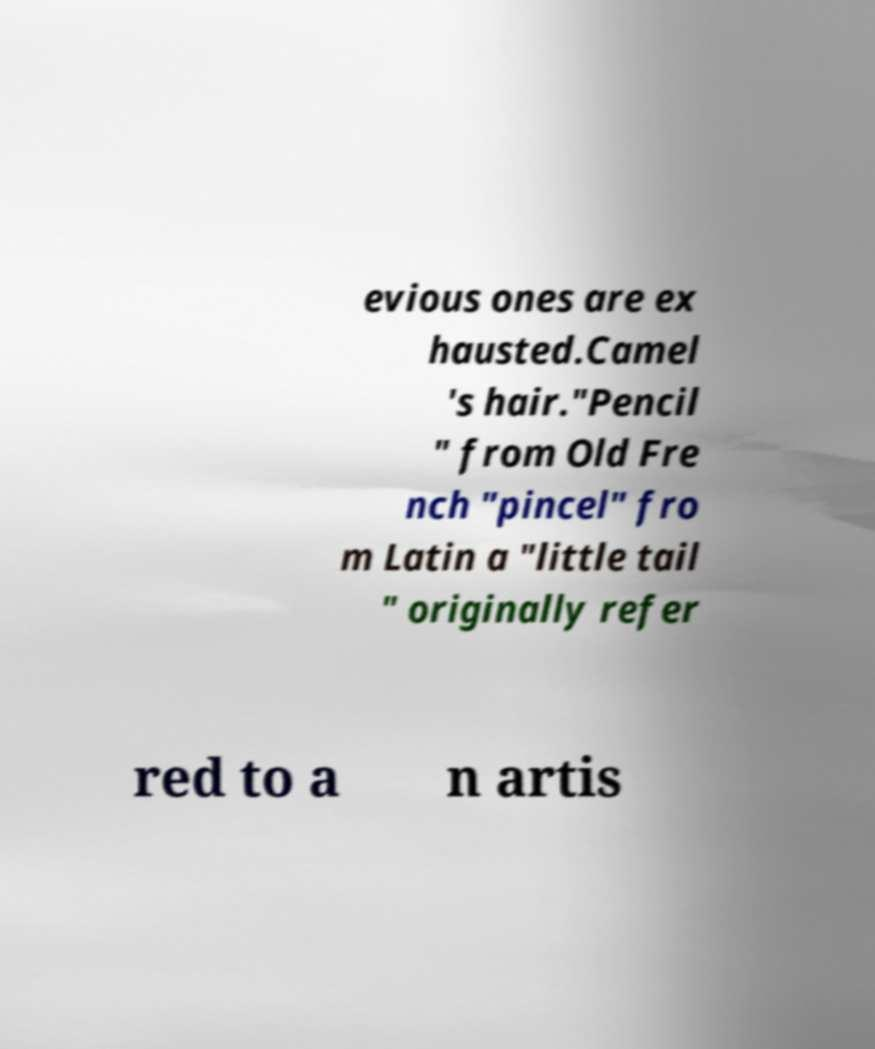For documentation purposes, I need the text within this image transcribed. Could you provide that? evious ones are ex hausted.Camel 's hair."Pencil " from Old Fre nch "pincel" fro m Latin a "little tail " originally refer red to a n artis 